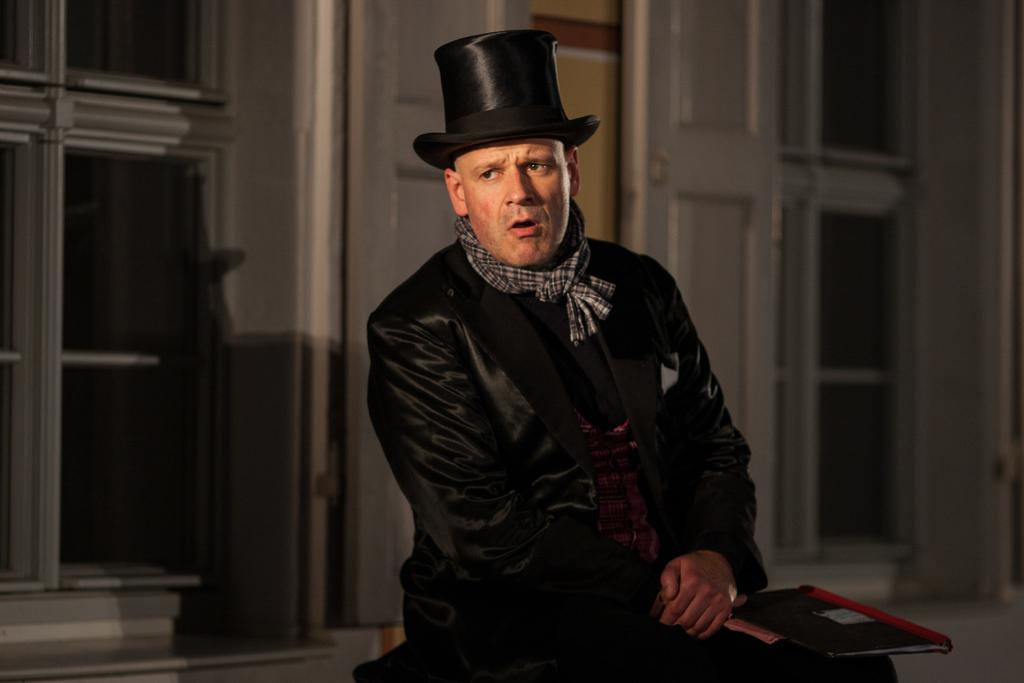What is present in the image? There is a person in the image. Can you describe the person's attire? The person is wearing clothes and a hat. What object is the person holding? The person is holding a notebook. What can be seen in the background of the image? There is a building in the background of the image. How many clocks are visible in the image? There are no clocks visible in the image. What type of crime is being committed in the image? There is no crime being committed in the image; it features a person holding a notebook and wearing a hat. 